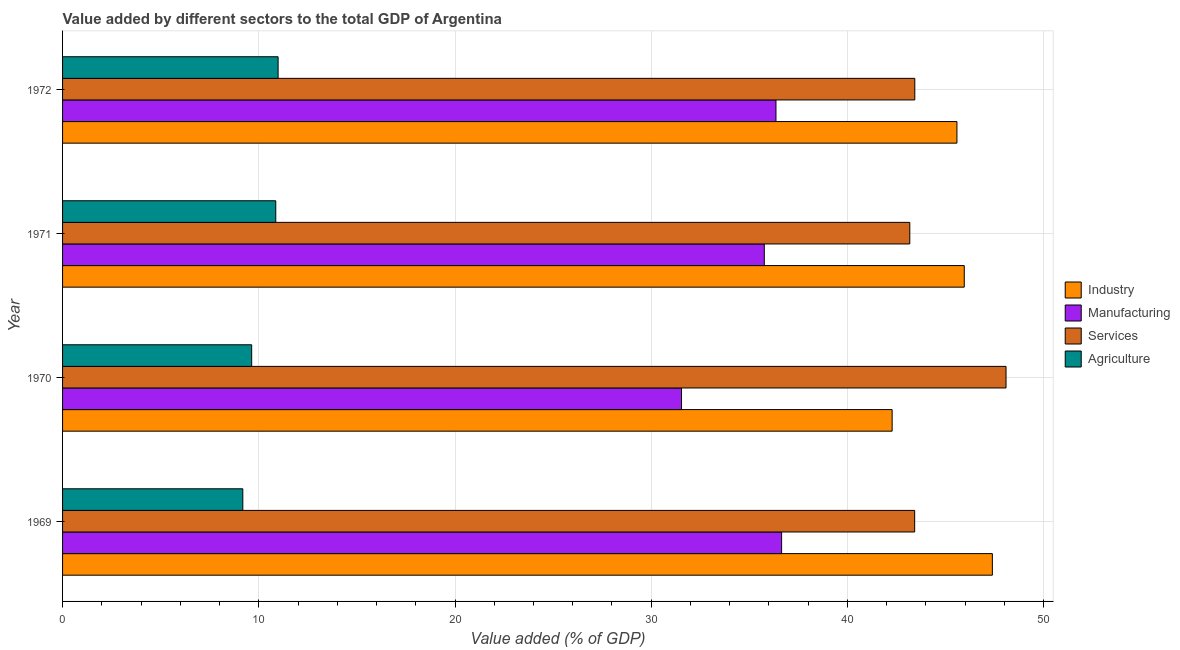How many different coloured bars are there?
Give a very brief answer. 4. How many groups of bars are there?
Your answer should be very brief. 4. Are the number of bars per tick equal to the number of legend labels?
Ensure brevity in your answer.  Yes. How many bars are there on the 2nd tick from the top?
Provide a short and direct response. 4. How many bars are there on the 3rd tick from the bottom?
Provide a succinct answer. 4. What is the label of the 2nd group of bars from the top?
Make the answer very short. 1971. What is the value added by services sector in 1969?
Make the answer very short. 43.43. Across all years, what is the maximum value added by services sector?
Give a very brief answer. 48.08. Across all years, what is the minimum value added by industrial sector?
Offer a very short reply. 42.28. In which year was the value added by manufacturing sector maximum?
Make the answer very short. 1969. What is the total value added by manufacturing sector in the graph?
Your answer should be compact. 140.31. What is the difference between the value added by industrial sector in 1971 and that in 1972?
Give a very brief answer. 0.37. What is the difference between the value added by manufacturing sector in 1970 and the value added by industrial sector in 1971?
Your answer should be very brief. -14.41. What is the average value added by services sector per year?
Provide a succinct answer. 44.53. In the year 1971, what is the difference between the value added by services sector and value added by agricultural sector?
Give a very brief answer. 32.31. What is the ratio of the value added by industrial sector in 1970 to that in 1972?
Ensure brevity in your answer.  0.93. Is the difference between the value added by manufacturing sector in 1969 and 1972 greater than the difference between the value added by industrial sector in 1969 and 1972?
Your answer should be compact. No. What is the difference between the highest and the second highest value added by services sector?
Keep it short and to the point. 4.65. What is the difference between the highest and the lowest value added by services sector?
Your answer should be compact. 4.9. Is it the case that in every year, the sum of the value added by services sector and value added by industrial sector is greater than the sum of value added by manufacturing sector and value added by agricultural sector?
Provide a succinct answer. No. What does the 4th bar from the top in 1971 represents?
Ensure brevity in your answer.  Industry. What does the 1st bar from the bottom in 1971 represents?
Your answer should be compact. Industry. Is it the case that in every year, the sum of the value added by industrial sector and value added by manufacturing sector is greater than the value added by services sector?
Your answer should be compact. Yes. How many bars are there?
Provide a succinct answer. 16. How many years are there in the graph?
Provide a short and direct response. 4. What is the difference between two consecutive major ticks on the X-axis?
Keep it short and to the point. 10. Does the graph contain any zero values?
Offer a terse response. No. Where does the legend appear in the graph?
Provide a short and direct response. Center right. How are the legend labels stacked?
Give a very brief answer. Vertical. What is the title of the graph?
Provide a succinct answer. Value added by different sectors to the total GDP of Argentina. Does "UNRWA" appear as one of the legend labels in the graph?
Give a very brief answer. No. What is the label or title of the X-axis?
Ensure brevity in your answer.  Value added (% of GDP). What is the label or title of the Y-axis?
Give a very brief answer. Year. What is the Value added (% of GDP) in Industry in 1969?
Keep it short and to the point. 47.39. What is the Value added (% of GDP) of Manufacturing in 1969?
Offer a terse response. 36.65. What is the Value added (% of GDP) of Services in 1969?
Offer a terse response. 43.43. What is the Value added (% of GDP) of Agriculture in 1969?
Your answer should be very brief. 9.19. What is the Value added (% of GDP) of Industry in 1970?
Provide a short and direct response. 42.28. What is the Value added (% of GDP) in Manufacturing in 1970?
Offer a terse response. 31.54. What is the Value added (% of GDP) of Services in 1970?
Make the answer very short. 48.08. What is the Value added (% of GDP) of Agriculture in 1970?
Provide a short and direct response. 9.64. What is the Value added (% of GDP) in Industry in 1971?
Make the answer very short. 45.96. What is the Value added (% of GDP) of Manufacturing in 1971?
Your answer should be compact. 35.76. What is the Value added (% of GDP) of Services in 1971?
Your response must be concise. 43.18. What is the Value added (% of GDP) of Agriculture in 1971?
Offer a very short reply. 10.87. What is the Value added (% of GDP) in Industry in 1972?
Keep it short and to the point. 45.58. What is the Value added (% of GDP) of Manufacturing in 1972?
Ensure brevity in your answer.  36.36. What is the Value added (% of GDP) in Services in 1972?
Offer a very short reply. 43.43. What is the Value added (% of GDP) in Agriculture in 1972?
Give a very brief answer. 10.98. Across all years, what is the maximum Value added (% of GDP) of Industry?
Offer a very short reply. 47.39. Across all years, what is the maximum Value added (% of GDP) of Manufacturing?
Provide a short and direct response. 36.65. Across all years, what is the maximum Value added (% of GDP) of Services?
Your answer should be compact. 48.08. Across all years, what is the maximum Value added (% of GDP) of Agriculture?
Provide a succinct answer. 10.98. Across all years, what is the minimum Value added (% of GDP) in Industry?
Provide a succinct answer. 42.28. Across all years, what is the minimum Value added (% of GDP) in Manufacturing?
Ensure brevity in your answer.  31.54. Across all years, what is the minimum Value added (% of GDP) of Services?
Ensure brevity in your answer.  43.18. Across all years, what is the minimum Value added (% of GDP) of Agriculture?
Your answer should be very brief. 9.19. What is the total Value added (% of GDP) in Industry in the graph?
Provide a short and direct response. 181.2. What is the total Value added (% of GDP) of Manufacturing in the graph?
Provide a succinct answer. 140.31. What is the total Value added (% of GDP) in Services in the graph?
Provide a succinct answer. 178.12. What is the total Value added (% of GDP) in Agriculture in the graph?
Provide a succinct answer. 40.67. What is the difference between the Value added (% of GDP) of Industry in 1969 and that in 1970?
Provide a short and direct response. 5.11. What is the difference between the Value added (% of GDP) of Manufacturing in 1969 and that in 1970?
Keep it short and to the point. 5.1. What is the difference between the Value added (% of GDP) in Services in 1969 and that in 1970?
Offer a terse response. -4.66. What is the difference between the Value added (% of GDP) of Agriculture in 1969 and that in 1970?
Keep it short and to the point. -0.45. What is the difference between the Value added (% of GDP) in Industry in 1969 and that in 1971?
Make the answer very short. 1.43. What is the difference between the Value added (% of GDP) in Manufacturing in 1969 and that in 1971?
Ensure brevity in your answer.  0.88. What is the difference between the Value added (% of GDP) of Services in 1969 and that in 1971?
Keep it short and to the point. 0.25. What is the difference between the Value added (% of GDP) of Agriculture in 1969 and that in 1971?
Ensure brevity in your answer.  -1.68. What is the difference between the Value added (% of GDP) of Industry in 1969 and that in 1972?
Offer a very short reply. 1.8. What is the difference between the Value added (% of GDP) of Manufacturing in 1969 and that in 1972?
Provide a short and direct response. 0.29. What is the difference between the Value added (% of GDP) of Services in 1969 and that in 1972?
Keep it short and to the point. -0.01. What is the difference between the Value added (% of GDP) of Agriculture in 1969 and that in 1972?
Provide a succinct answer. -1.8. What is the difference between the Value added (% of GDP) of Industry in 1970 and that in 1971?
Make the answer very short. -3.68. What is the difference between the Value added (% of GDP) of Manufacturing in 1970 and that in 1971?
Provide a succinct answer. -4.22. What is the difference between the Value added (% of GDP) of Services in 1970 and that in 1971?
Provide a short and direct response. 4.9. What is the difference between the Value added (% of GDP) of Agriculture in 1970 and that in 1971?
Ensure brevity in your answer.  -1.23. What is the difference between the Value added (% of GDP) of Industry in 1970 and that in 1972?
Make the answer very short. -3.3. What is the difference between the Value added (% of GDP) of Manufacturing in 1970 and that in 1972?
Give a very brief answer. -4.81. What is the difference between the Value added (% of GDP) in Services in 1970 and that in 1972?
Ensure brevity in your answer.  4.65. What is the difference between the Value added (% of GDP) of Agriculture in 1970 and that in 1972?
Give a very brief answer. -1.35. What is the difference between the Value added (% of GDP) of Industry in 1971 and that in 1972?
Ensure brevity in your answer.  0.37. What is the difference between the Value added (% of GDP) of Manufacturing in 1971 and that in 1972?
Offer a terse response. -0.59. What is the difference between the Value added (% of GDP) in Services in 1971 and that in 1972?
Provide a succinct answer. -0.25. What is the difference between the Value added (% of GDP) of Agriculture in 1971 and that in 1972?
Ensure brevity in your answer.  -0.12. What is the difference between the Value added (% of GDP) in Industry in 1969 and the Value added (% of GDP) in Manufacturing in 1970?
Your answer should be very brief. 15.84. What is the difference between the Value added (% of GDP) of Industry in 1969 and the Value added (% of GDP) of Services in 1970?
Your answer should be compact. -0.7. What is the difference between the Value added (% of GDP) of Industry in 1969 and the Value added (% of GDP) of Agriculture in 1970?
Keep it short and to the point. 37.75. What is the difference between the Value added (% of GDP) in Manufacturing in 1969 and the Value added (% of GDP) in Services in 1970?
Your answer should be very brief. -11.44. What is the difference between the Value added (% of GDP) of Manufacturing in 1969 and the Value added (% of GDP) of Agriculture in 1970?
Ensure brevity in your answer.  27.01. What is the difference between the Value added (% of GDP) in Services in 1969 and the Value added (% of GDP) in Agriculture in 1970?
Give a very brief answer. 33.79. What is the difference between the Value added (% of GDP) in Industry in 1969 and the Value added (% of GDP) in Manufacturing in 1971?
Offer a very short reply. 11.62. What is the difference between the Value added (% of GDP) of Industry in 1969 and the Value added (% of GDP) of Services in 1971?
Offer a terse response. 4.21. What is the difference between the Value added (% of GDP) of Industry in 1969 and the Value added (% of GDP) of Agriculture in 1971?
Provide a succinct answer. 36.52. What is the difference between the Value added (% of GDP) of Manufacturing in 1969 and the Value added (% of GDP) of Services in 1971?
Your answer should be very brief. -6.53. What is the difference between the Value added (% of GDP) of Manufacturing in 1969 and the Value added (% of GDP) of Agriculture in 1971?
Ensure brevity in your answer.  25.78. What is the difference between the Value added (% of GDP) of Services in 1969 and the Value added (% of GDP) of Agriculture in 1971?
Your answer should be compact. 32.56. What is the difference between the Value added (% of GDP) of Industry in 1969 and the Value added (% of GDP) of Manufacturing in 1972?
Offer a terse response. 11.03. What is the difference between the Value added (% of GDP) in Industry in 1969 and the Value added (% of GDP) in Services in 1972?
Your response must be concise. 3.95. What is the difference between the Value added (% of GDP) of Industry in 1969 and the Value added (% of GDP) of Agriculture in 1972?
Give a very brief answer. 36.4. What is the difference between the Value added (% of GDP) in Manufacturing in 1969 and the Value added (% of GDP) in Services in 1972?
Your response must be concise. -6.79. What is the difference between the Value added (% of GDP) in Manufacturing in 1969 and the Value added (% of GDP) in Agriculture in 1972?
Make the answer very short. 25.66. What is the difference between the Value added (% of GDP) in Services in 1969 and the Value added (% of GDP) in Agriculture in 1972?
Give a very brief answer. 32.44. What is the difference between the Value added (% of GDP) of Industry in 1970 and the Value added (% of GDP) of Manufacturing in 1971?
Your answer should be very brief. 6.52. What is the difference between the Value added (% of GDP) in Industry in 1970 and the Value added (% of GDP) in Services in 1971?
Your answer should be compact. -0.9. What is the difference between the Value added (% of GDP) in Industry in 1970 and the Value added (% of GDP) in Agriculture in 1971?
Offer a very short reply. 31.41. What is the difference between the Value added (% of GDP) of Manufacturing in 1970 and the Value added (% of GDP) of Services in 1971?
Give a very brief answer. -11.63. What is the difference between the Value added (% of GDP) of Manufacturing in 1970 and the Value added (% of GDP) of Agriculture in 1971?
Your answer should be very brief. 20.68. What is the difference between the Value added (% of GDP) in Services in 1970 and the Value added (% of GDP) in Agriculture in 1971?
Your response must be concise. 37.22. What is the difference between the Value added (% of GDP) in Industry in 1970 and the Value added (% of GDP) in Manufacturing in 1972?
Your answer should be compact. 5.92. What is the difference between the Value added (% of GDP) of Industry in 1970 and the Value added (% of GDP) of Services in 1972?
Ensure brevity in your answer.  -1.15. What is the difference between the Value added (% of GDP) in Industry in 1970 and the Value added (% of GDP) in Agriculture in 1972?
Make the answer very short. 31.29. What is the difference between the Value added (% of GDP) of Manufacturing in 1970 and the Value added (% of GDP) of Services in 1972?
Provide a short and direct response. -11.89. What is the difference between the Value added (% of GDP) in Manufacturing in 1970 and the Value added (% of GDP) in Agriculture in 1972?
Offer a terse response. 20.56. What is the difference between the Value added (% of GDP) in Services in 1970 and the Value added (% of GDP) in Agriculture in 1972?
Ensure brevity in your answer.  37.1. What is the difference between the Value added (% of GDP) of Industry in 1971 and the Value added (% of GDP) of Manufacturing in 1972?
Offer a very short reply. 9.6. What is the difference between the Value added (% of GDP) of Industry in 1971 and the Value added (% of GDP) of Services in 1972?
Offer a terse response. 2.52. What is the difference between the Value added (% of GDP) in Industry in 1971 and the Value added (% of GDP) in Agriculture in 1972?
Offer a very short reply. 34.97. What is the difference between the Value added (% of GDP) of Manufacturing in 1971 and the Value added (% of GDP) of Services in 1972?
Ensure brevity in your answer.  -7.67. What is the difference between the Value added (% of GDP) in Manufacturing in 1971 and the Value added (% of GDP) in Agriculture in 1972?
Offer a terse response. 24.78. What is the difference between the Value added (% of GDP) in Services in 1971 and the Value added (% of GDP) in Agriculture in 1972?
Provide a short and direct response. 32.19. What is the average Value added (% of GDP) in Industry per year?
Provide a succinct answer. 45.3. What is the average Value added (% of GDP) of Manufacturing per year?
Give a very brief answer. 35.08. What is the average Value added (% of GDP) of Services per year?
Offer a terse response. 44.53. What is the average Value added (% of GDP) of Agriculture per year?
Provide a short and direct response. 10.17. In the year 1969, what is the difference between the Value added (% of GDP) of Industry and Value added (% of GDP) of Manufacturing?
Make the answer very short. 10.74. In the year 1969, what is the difference between the Value added (% of GDP) of Industry and Value added (% of GDP) of Services?
Give a very brief answer. 3.96. In the year 1969, what is the difference between the Value added (% of GDP) of Industry and Value added (% of GDP) of Agriculture?
Your answer should be compact. 38.2. In the year 1969, what is the difference between the Value added (% of GDP) of Manufacturing and Value added (% of GDP) of Services?
Offer a very short reply. -6.78. In the year 1969, what is the difference between the Value added (% of GDP) of Manufacturing and Value added (% of GDP) of Agriculture?
Provide a short and direct response. 27.46. In the year 1969, what is the difference between the Value added (% of GDP) of Services and Value added (% of GDP) of Agriculture?
Offer a terse response. 34.24. In the year 1970, what is the difference between the Value added (% of GDP) of Industry and Value added (% of GDP) of Manufacturing?
Make the answer very short. 10.73. In the year 1970, what is the difference between the Value added (% of GDP) of Industry and Value added (% of GDP) of Services?
Give a very brief answer. -5.8. In the year 1970, what is the difference between the Value added (% of GDP) of Industry and Value added (% of GDP) of Agriculture?
Give a very brief answer. 32.64. In the year 1970, what is the difference between the Value added (% of GDP) in Manufacturing and Value added (% of GDP) in Services?
Ensure brevity in your answer.  -16.54. In the year 1970, what is the difference between the Value added (% of GDP) of Manufacturing and Value added (% of GDP) of Agriculture?
Give a very brief answer. 21.91. In the year 1970, what is the difference between the Value added (% of GDP) in Services and Value added (% of GDP) in Agriculture?
Provide a succinct answer. 38.45. In the year 1971, what is the difference between the Value added (% of GDP) of Industry and Value added (% of GDP) of Manufacturing?
Offer a very short reply. 10.19. In the year 1971, what is the difference between the Value added (% of GDP) in Industry and Value added (% of GDP) in Services?
Keep it short and to the point. 2.78. In the year 1971, what is the difference between the Value added (% of GDP) of Industry and Value added (% of GDP) of Agriculture?
Ensure brevity in your answer.  35.09. In the year 1971, what is the difference between the Value added (% of GDP) of Manufacturing and Value added (% of GDP) of Services?
Keep it short and to the point. -7.42. In the year 1971, what is the difference between the Value added (% of GDP) in Manufacturing and Value added (% of GDP) in Agriculture?
Make the answer very short. 24.9. In the year 1971, what is the difference between the Value added (% of GDP) of Services and Value added (% of GDP) of Agriculture?
Your answer should be very brief. 32.31. In the year 1972, what is the difference between the Value added (% of GDP) in Industry and Value added (% of GDP) in Manufacturing?
Offer a very short reply. 9.22. In the year 1972, what is the difference between the Value added (% of GDP) in Industry and Value added (% of GDP) in Services?
Make the answer very short. 2.15. In the year 1972, what is the difference between the Value added (% of GDP) in Industry and Value added (% of GDP) in Agriculture?
Your answer should be very brief. 34.6. In the year 1972, what is the difference between the Value added (% of GDP) of Manufacturing and Value added (% of GDP) of Services?
Keep it short and to the point. -7.08. In the year 1972, what is the difference between the Value added (% of GDP) of Manufacturing and Value added (% of GDP) of Agriculture?
Offer a very short reply. 25.37. In the year 1972, what is the difference between the Value added (% of GDP) of Services and Value added (% of GDP) of Agriculture?
Offer a terse response. 32.45. What is the ratio of the Value added (% of GDP) of Industry in 1969 to that in 1970?
Offer a terse response. 1.12. What is the ratio of the Value added (% of GDP) in Manufacturing in 1969 to that in 1970?
Give a very brief answer. 1.16. What is the ratio of the Value added (% of GDP) of Services in 1969 to that in 1970?
Your answer should be very brief. 0.9. What is the ratio of the Value added (% of GDP) of Agriculture in 1969 to that in 1970?
Make the answer very short. 0.95. What is the ratio of the Value added (% of GDP) of Industry in 1969 to that in 1971?
Provide a short and direct response. 1.03. What is the ratio of the Value added (% of GDP) of Manufacturing in 1969 to that in 1971?
Your response must be concise. 1.02. What is the ratio of the Value added (% of GDP) in Agriculture in 1969 to that in 1971?
Keep it short and to the point. 0.85. What is the ratio of the Value added (% of GDP) in Industry in 1969 to that in 1972?
Keep it short and to the point. 1.04. What is the ratio of the Value added (% of GDP) of Manufacturing in 1969 to that in 1972?
Ensure brevity in your answer.  1.01. What is the ratio of the Value added (% of GDP) of Services in 1969 to that in 1972?
Your answer should be compact. 1. What is the ratio of the Value added (% of GDP) of Agriculture in 1969 to that in 1972?
Your response must be concise. 0.84. What is the ratio of the Value added (% of GDP) in Manufacturing in 1970 to that in 1971?
Your response must be concise. 0.88. What is the ratio of the Value added (% of GDP) in Services in 1970 to that in 1971?
Provide a short and direct response. 1.11. What is the ratio of the Value added (% of GDP) in Agriculture in 1970 to that in 1971?
Your answer should be very brief. 0.89. What is the ratio of the Value added (% of GDP) in Industry in 1970 to that in 1972?
Keep it short and to the point. 0.93. What is the ratio of the Value added (% of GDP) of Manufacturing in 1970 to that in 1972?
Ensure brevity in your answer.  0.87. What is the ratio of the Value added (% of GDP) of Services in 1970 to that in 1972?
Offer a very short reply. 1.11. What is the ratio of the Value added (% of GDP) in Agriculture in 1970 to that in 1972?
Make the answer very short. 0.88. What is the ratio of the Value added (% of GDP) in Industry in 1971 to that in 1972?
Provide a short and direct response. 1.01. What is the ratio of the Value added (% of GDP) of Manufacturing in 1971 to that in 1972?
Make the answer very short. 0.98. What is the ratio of the Value added (% of GDP) of Services in 1971 to that in 1972?
Give a very brief answer. 0.99. What is the difference between the highest and the second highest Value added (% of GDP) in Industry?
Your answer should be compact. 1.43. What is the difference between the highest and the second highest Value added (% of GDP) of Manufacturing?
Offer a terse response. 0.29. What is the difference between the highest and the second highest Value added (% of GDP) of Services?
Ensure brevity in your answer.  4.65. What is the difference between the highest and the second highest Value added (% of GDP) in Agriculture?
Your answer should be compact. 0.12. What is the difference between the highest and the lowest Value added (% of GDP) in Industry?
Your response must be concise. 5.11. What is the difference between the highest and the lowest Value added (% of GDP) in Manufacturing?
Ensure brevity in your answer.  5.1. What is the difference between the highest and the lowest Value added (% of GDP) in Services?
Make the answer very short. 4.9. What is the difference between the highest and the lowest Value added (% of GDP) of Agriculture?
Keep it short and to the point. 1.8. 